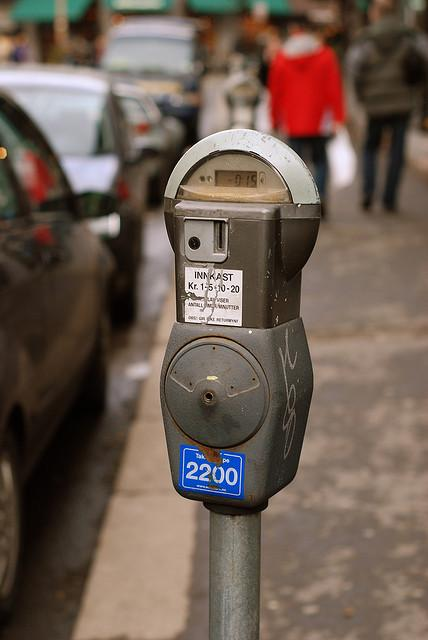What number do you get if you add 10 to the number at the bottom of the meter?

Choices:
A) 8610
B) 2210
C) 445
D) 3750 2210 